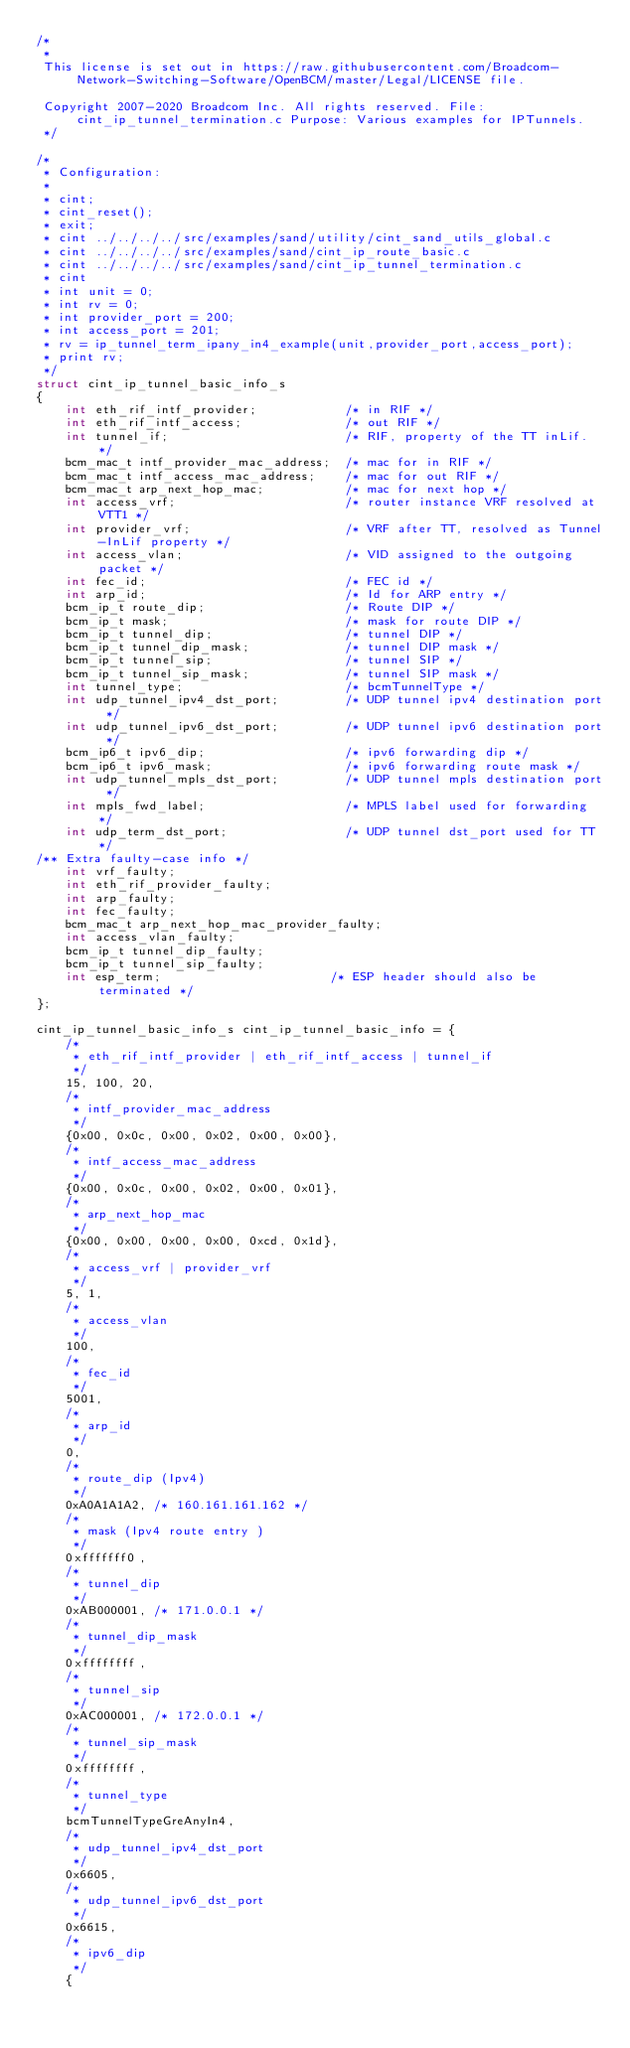Convert code to text. <code><loc_0><loc_0><loc_500><loc_500><_C_>/*
 * 
 This license is set out in https://raw.githubusercontent.com/Broadcom-Network-Switching-Software/OpenBCM/master/Legal/LICENSE file.
 
 Copyright 2007-2020 Broadcom Inc. All rights reserved. File: cint_ip_tunnel_termination.c Purpose: Various examples for IPTunnels.
 */

/*
 * Configuration:
 *
 * cint;
 * cint_reset();
 * exit;
 * cint ../../../../src/examples/sand/utility/cint_sand_utils_global.c
 * cint ../../../../src/examples/sand/cint_ip_route_basic.c
 * cint ../../../../src/examples/sand/cint_ip_tunnel_termination.c
 * cint
 * int unit = 0;
 * int rv = 0;
 * int provider_port = 200;
 * int access_port = 201;
 * rv = ip_tunnel_term_ipany_in4_example(unit,provider_port,access_port);
 * print rv;
 */
struct cint_ip_tunnel_basic_info_s
{
    int eth_rif_intf_provider;            /* in RIF */
    int eth_rif_intf_access;              /* out RIF */
    int tunnel_if;                        /* RIF, property of the TT inLif. */
    bcm_mac_t intf_provider_mac_address;  /* mac for in RIF */
    bcm_mac_t intf_access_mac_address;    /* mac for out RIF */
    bcm_mac_t arp_next_hop_mac;           /* mac for next hop */
    int access_vrf;                       /* router instance VRF resolved at VTT1 */
    int provider_vrf;                     /* VRF after TT, resolved as Tunnel-InLif property */
    int access_vlan;                      /* VID assigned to the outgoing packet */
    int fec_id;                           /* FEC id */
    int arp_id;                           /* Id for ARP entry */
    bcm_ip_t route_dip;                   /* Route DIP */
    bcm_ip_t mask;                        /* mask for route DIP */
    bcm_ip_t tunnel_dip;                  /* tunnel DIP */
    bcm_ip_t tunnel_dip_mask;             /* tunnel DIP mask */
    bcm_ip_t tunnel_sip;                  /* tunnel SIP */
    bcm_ip_t tunnel_sip_mask;             /* tunnel SIP mask */
    int tunnel_type;                      /* bcmTunnelType */
    int udp_tunnel_ipv4_dst_port;         /* UDP tunnel ipv4 destination port */
    int udp_tunnel_ipv6_dst_port;         /* UDP tunnel ipv6 destination port */
    bcm_ip6_t ipv6_dip;                   /* ipv6 forwarding dip */
    bcm_ip6_t ipv6_mask;                  /* ipv6 forwarding route mask */
    int udp_tunnel_mpls_dst_port;         /* UDP tunnel mpls destination port */
    int mpls_fwd_label;                   /* MPLS label used for forwarding */
    int udp_term_dst_port;                /* UDP tunnel dst_port used for TT */
/** Extra faulty-case info */
    int vrf_faulty;
    int eth_rif_provider_faulty;
    int arp_faulty;
    int fec_faulty;
    bcm_mac_t arp_next_hop_mac_provider_faulty;
    int access_vlan_faulty;
    bcm_ip_t tunnel_dip_faulty;
    bcm_ip_t tunnel_sip_faulty;
    int esp_term;                       /* ESP header should also be terminated */
};

cint_ip_tunnel_basic_info_s cint_ip_tunnel_basic_info = {
    /*
     * eth_rif_intf_provider | eth_rif_intf_access | tunnel_if
     */
    15, 100, 20,
    /*
     * intf_provider_mac_address
     */
    {0x00, 0x0c, 0x00, 0x02, 0x00, 0x00},
    /*
     * intf_access_mac_address
     */
    {0x00, 0x0c, 0x00, 0x02, 0x00, 0x01},
    /*
     * arp_next_hop_mac
     */
    {0x00, 0x00, 0x00, 0x00, 0xcd, 0x1d},
    /*
     * access_vrf | provider_vrf
     */
    5, 1,
    /*
     * access_vlan
     */
    100,
    /*
     * fec_id
     */
    5001,
    /*
     * arp_id
     */
    0,
    /*
     * route_dip (Ipv4)
     */
    0xA0A1A1A2, /* 160.161.161.162 */
    /*
     * mask (Ipv4 route entry )
     */
    0xfffffff0,
    /*
     * tunnel_dip
     */
    0xAB000001, /* 171.0.0.1 */
    /*
     * tunnel_dip_mask
     */
    0xffffffff,
    /*
     * tunnel_sip
     */
    0xAC000001, /* 172.0.0.1 */
    /*
     * tunnel_sip_mask
     */
    0xffffffff,
    /*
     * tunnel_type
     */
    bcmTunnelTypeGreAnyIn4,
    /*
     * udp_tunnel_ipv4_dst_port
     */
    0x6605,
    /*
     * udp_tunnel_ipv6_dst_port
     */
    0x6615,
    /*
     * ipv6_dip
     */
    {</code> 